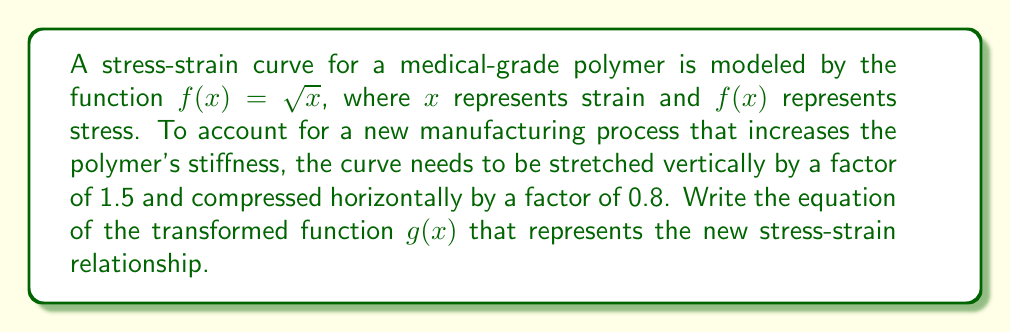Could you help me with this problem? To transform the original function $f(x) = \sqrt{x}$, we'll apply the following steps:

1. Vertical stretch by a factor of 1.5:
   $h(x) = 1.5f(x) = 1.5\sqrt{x}$

2. Horizontal compression by a factor of 0.8:
   To compress horizontally, we divide the input by 0.8 (equivalent to multiplying by $\frac{1}{0.8} = 1.25$):
   $g(x) = h(\frac{x}{0.8}) = 1.5\sqrt{\frac{x}{0.8}}$

3. Simplify the expression under the square root:
   $g(x) = 1.5\sqrt{\frac{x}{0.8}} = 1.5\sqrt{\frac{5x}{4}}$

4. Simplify the coefficient outside the square root:
   $g(x) = 1.5\sqrt{\frac{5x}{4}} = 1.5 \cdot \frac{\sqrt{5}}{\sqrt{4}} \cdot \sqrt{x} = 1.5 \cdot \frac{\sqrt{5}}{2} \cdot \sqrt{x}$

5. Combine the constants:
   $g(x) = \frac{3\sqrt{5}}{4}\sqrt{x}$

Therefore, the equation of the transformed function $g(x)$ is $\frac{3\sqrt{5}}{4}\sqrt{x}$.
Answer: $g(x) = \frac{3\sqrt{5}}{4}\sqrt{x}$ 